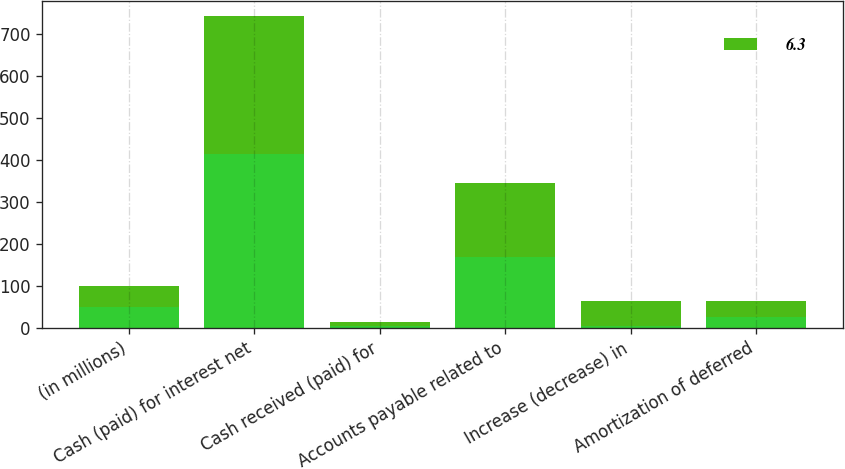Convert chart. <chart><loc_0><loc_0><loc_500><loc_500><stacked_bar_chart><ecel><fcel>(in millions)<fcel>Cash (paid) for interest net<fcel>Cash received (paid) for<fcel>Accounts payable related to<fcel>Increase (decrease) in<fcel>Amortization of deferred<nl><fcel>nan<fcel>50.05<fcel>413.7<fcel>5.2<fcel>169.2<fcel>4.6<fcel>24.9<nl><fcel>6.3<fcel>50.05<fcel>329.6<fcel>9.3<fcel>177.1<fcel>60.2<fcel>39.9<nl></chart> 